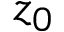<formula> <loc_0><loc_0><loc_500><loc_500>z _ { 0 }</formula> 